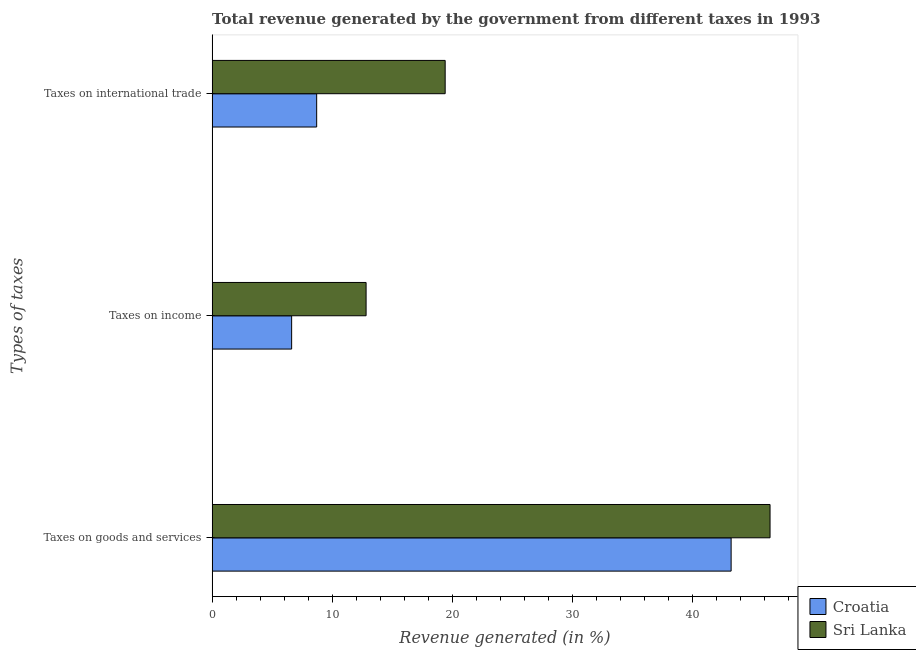How many different coloured bars are there?
Provide a succinct answer. 2. How many bars are there on the 1st tick from the bottom?
Keep it short and to the point. 2. What is the label of the 1st group of bars from the top?
Keep it short and to the point. Taxes on international trade. What is the percentage of revenue generated by taxes on income in Sri Lanka?
Give a very brief answer. 12.83. Across all countries, what is the maximum percentage of revenue generated by taxes on goods and services?
Make the answer very short. 46.49. Across all countries, what is the minimum percentage of revenue generated by tax on international trade?
Give a very brief answer. 8.71. In which country was the percentage of revenue generated by taxes on goods and services maximum?
Offer a terse response. Sri Lanka. In which country was the percentage of revenue generated by tax on international trade minimum?
Offer a very short reply. Croatia. What is the total percentage of revenue generated by taxes on income in the graph?
Provide a succinct answer. 19.46. What is the difference between the percentage of revenue generated by tax on international trade in Sri Lanka and that in Croatia?
Ensure brevity in your answer.  10.71. What is the difference between the percentage of revenue generated by tax on international trade in Croatia and the percentage of revenue generated by taxes on income in Sri Lanka?
Provide a short and direct response. -4.12. What is the average percentage of revenue generated by tax on international trade per country?
Offer a very short reply. 14.07. What is the difference between the percentage of revenue generated by tax on international trade and percentage of revenue generated by taxes on goods and services in Sri Lanka?
Give a very brief answer. -27.07. In how many countries, is the percentage of revenue generated by tax on international trade greater than 42 %?
Keep it short and to the point. 0. What is the ratio of the percentage of revenue generated by taxes on income in Sri Lanka to that in Croatia?
Give a very brief answer. 1.94. Is the difference between the percentage of revenue generated by tax on international trade in Sri Lanka and Croatia greater than the difference between the percentage of revenue generated by taxes on goods and services in Sri Lanka and Croatia?
Your answer should be very brief. Yes. What is the difference between the highest and the second highest percentage of revenue generated by taxes on goods and services?
Provide a succinct answer. 3.24. What is the difference between the highest and the lowest percentage of revenue generated by taxes on goods and services?
Keep it short and to the point. 3.24. In how many countries, is the percentage of revenue generated by taxes on goods and services greater than the average percentage of revenue generated by taxes on goods and services taken over all countries?
Your answer should be compact. 1. Is the sum of the percentage of revenue generated by tax on international trade in Croatia and Sri Lanka greater than the maximum percentage of revenue generated by taxes on income across all countries?
Offer a very short reply. Yes. What does the 2nd bar from the top in Taxes on goods and services represents?
Your answer should be very brief. Croatia. What does the 1st bar from the bottom in Taxes on goods and services represents?
Offer a terse response. Croatia. Where does the legend appear in the graph?
Offer a terse response. Bottom right. How many legend labels are there?
Your answer should be very brief. 2. What is the title of the graph?
Keep it short and to the point. Total revenue generated by the government from different taxes in 1993. What is the label or title of the X-axis?
Offer a terse response. Revenue generated (in %). What is the label or title of the Y-axis?
Your response must be concise. Types of taxes. What is the Revenue generated (in %) in Croatia in Taxes on goods and services?
Make the answer very short. 43.25. What is the Revenue generated (in %) in Sri Lanka in Taxes on goods and services?
Keep it short and to the point. 46.49. What is the Revenue generated (in %) of Croatia in Taxes on income?
Your answer should be compact. 6.63. What is the Revenue generated (in %) in Sri Lanka in Taxes on income?
Your response must be concise. 12.83. What is the Revenue generated (in %) of Croatia in Taxes on international trade?
Keep it short and to the point. 8.71. What is the Revenue generated (in %) in Sri Lanka in Taxes on international trade?
Give a very brief answer. 19.42. Across all Types of taxes, what is the maximum Revenue generated (in %) in Croatia?
Your response must be concise. 43.25. Across all Types of taxes, what is the maximum Revenue generated (in %) of Sri Lanka?
Keep it short and to the point. 46.49. Across all Types of taxes, what is the minimum Revenue generated (in %) of Croatia?
Make the answer very short. 6.63. Across all Types of taxes, what is the minimum Revenue generated (in %) of Sri Lanka?
Provide a succinct answer. 12.83. What is the total Revenue generated (in %) in Croatia in the graph?
Ensure brevity in your answer.  58.59. What is the total Revenue generated (in %) in Sri Lanka in the graph?
Provide a short and direct response. 78.74. What is the difference between the Revenue generated (in %) of Croatia in Taxes on goods and services and that in Taxes on income?
Your answer should be very brief. 36.62. What is the difference between the Revenue generated (in %) in Sri Lanka in Taxes on goods and services and that in Taxes on income?
Provide a short and direct response. 33.66. What is the difference between the Revenue generated (in %) in Croatia in Taxes on goods and services and that in Taxes on international trade?
Keep it short and to the point. 34.54. What is the difference between the Revenue generated (in %) in Sri Lanka in Taxes on goods and services and that in Taxes on international trade?
Make the answer very short. 27.07. What is the difference between the Revenue generated (in %) of Croatia in Taxes on income and that in Taxes on international trade?
Offer a terse response. -2.09. What is the difference between the Revenue generated (in %) in Sri Lanka in Taxes on income and that in Taxes on international trade?
Make the answer very short. -6.59. What is the difference between the Revenue generated (in %) of Croatia in Taxes on goods and services and the Revenue generated (in %) of Sri Lanka in Taxes on income?
Provide a succinct answer. 30.42. What is the difference between the Revenue generated (in %) of Croatia in Taxes on goods and services and the Revenue generated (in %) of Sri Lanka in Taxes on international trade?
Your response must be concise. 23.83. What is the difference between the Revenue generated (in %) of Croatia in Taxes on income and the Revenue generated (in %) of Sri Lanka in Taxes on international trade?
Provide a succinct answer. -12.79. What is the average Revenue generated (in %) of Croatia per Types of taxes?
Offer a terse response. 19.53. What is the average Revenue generated (in %) in Sri Lanka per Types of taxes?
Offer a very short reply. 26.25. What is the difference between the Revenue generated (in %) in Croatia and Revenue generated (in %) in Sri Lanka in Taxes on goods and services?
Keep it short and to the point. -3.24. What is the difference between the Revenue generated (in %) of Croatia and Revenue generated (in %) of Sri Lanka in Taxes on income?
Your answer should be very brief. -6.2. What is the difference between the Revenue generated (in %) of Croatia and Revenue generated (in %) of Sri Lanka in Taxes on international trade?
Your response must be concise. -10.71. What is the ratio of the Revenue generated (in %) in Croatia in Taxes on goods and services to that in Taxes on income?
Provide a succinct answer. 6.53. What is the ratio of the Revenue generated (in %) in Sri Lanka in Taxes on goods and services to that in Taxes on income?
Your response must be concise. 3.62. What is the ratio of the Revenue generated (in %) of Croatia in Taxes on goods and services to that in Taxes on international trade?
Your answer should be compact. 4.96. What is the ratio of the Revenue generated (in %) of Sri Lanka in Taxes on goods and services to that in Taxes on international trade?
Your answer should be compact. 2.39. What is the ratio of the Revenue generated (in %) in Croatia in Taxes on income to that in Taxes on international trade?
Offer a very short reply. 0.76. What is the ratio of the Revenue generated (in %) of Sri Lanka in Taxes on income to that in Taxes on international trade?
Provide a short and direct response. 0.66. What is the difference between the highest and the second highest Revenue generated (in %) in Croatia?
Offer a very short reply. 34.54. What is the difference between the highest and the second highest Revenue generated (in %) in Sri Lanka?
Make the answer very short. 27.07. What is the difference between the highest and the lowest Revenue generated (in %) in Croatia?
Provide a short and direct response. 36.62. What is the difference between the highest and the lowest Revenue generated (in %) in Sri Lanka?
Give a very brief answer. 33.66. 